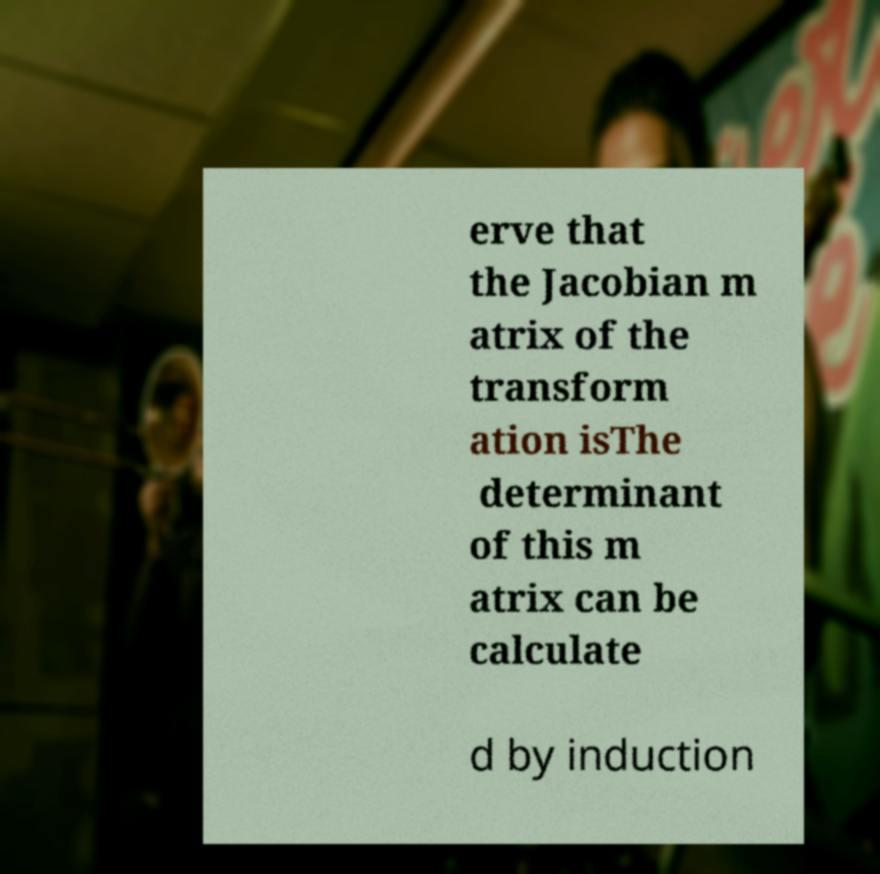Can you accurately transcribe the text from the provided image for me? erve that the Jacobian m atrix of the transform ation isThe determinant of this m atrix can be calculate d by induction 